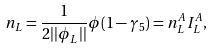Convert formula to latex. <formula><loc_0><loc_0><loc_500><loc_500>n _ { L } = \frac { 1 } { 2 | | \phi _ { L } | | } \phi ( 1 - \gamma _ { 5 } ) = n _ { L } ^ { A } I _ { L } ^ { A } ,</formula> 